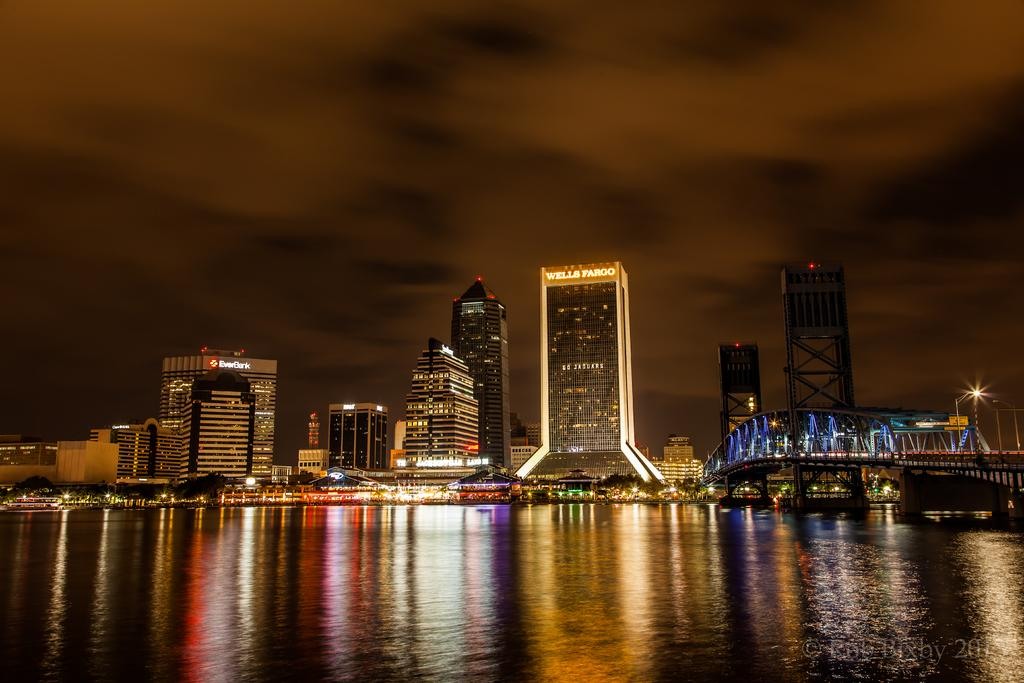Provide a one-sentence caption for the provided image. a night shot of buildings like Wells Fargo lit up at night. 